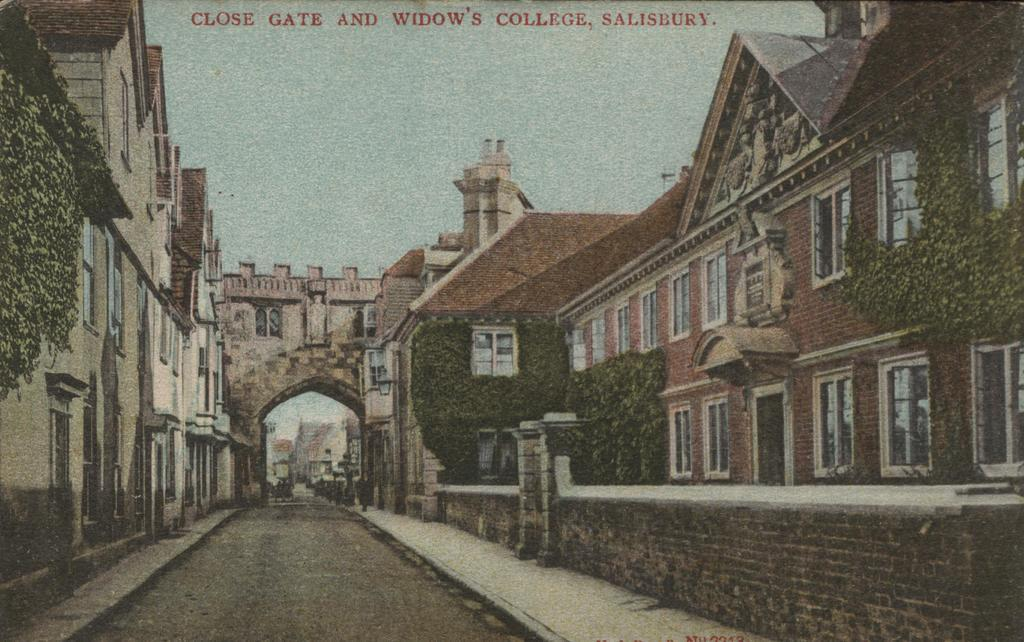What type of structures are present in the image? There are buildings with windows in the image. What other elements can be seen in the image besides the buildings? There are plants, an arch, and a road in the image. What is visible in the background of the image? The sky is visible in the background of the image. What type of humor can be found in the image? There is no humor present in the image; it is a scene featuring buildings, plants, an arch, a road, and the sky. 